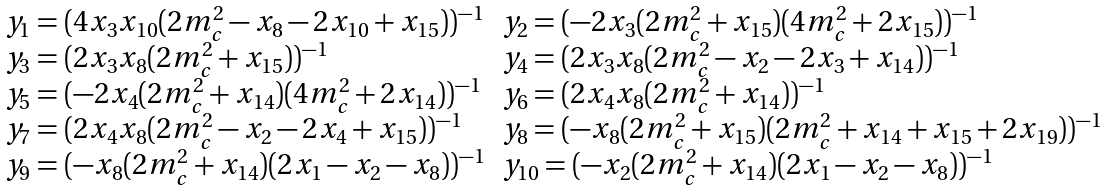Convert formula to latex. <formula><loc_0><loc_0><loc_500><loc_500>\begin{array} { l l l } & y _ { 1 } = ( 4 x _ { 3 } x _ { 1 0 } ( 2 { m ^ { 2 } _ { c } } - x _ { 8 } - 2 x _ { 1 0 } + x _ { 1 5 } ) ) ^ { - 1 } & y _ { 2 } = ( - 2 x _ { 3 } ( 2 { m ^ { 2 } _ { c } } + x _ { 1 5 } ) ( 4 { m ^ { 2 } _ { c } } + 2 x _ { 1 5 } ) ) ^ { - 1 } \\ & y _ { 3 } = ( 2 x _ { 3 } x _ { 8 } ( 2 { m ^ { 2 } _ { c } } + x _ { 1 5 } ) ) ^ { - 1 } & y _ { 4 } = ( 2 x _ { 3 } x _ { 8 } ( 2 { m ^ { 2 } _ { c } } - x _ { 2 } - 2 x _ { 3 } + x _ { 1 4 } ) ) ^ { - 1 } \\ & y _ { 5 } = ( - 2 x _ { 4 } ( 2 { m ^ { 2 } _ { c } } + x _ { 1 4 } ) ( 4 { m ^ { 2 } _ { c } } + 2 x _ { 1 4 } ) ) ^ { - 1 } & y _ { 6 } = ( 2 x _ { 4 } x _ { 8 } ( 2 { m ^ { 2 } _ { c } } + x _ { 1 4 } ) ) ^ { - 1 } \\ & y _ { 7 } = ( 2 x _ { 4 } x _ { 8 } ( 2 { m ^ { 2 } _ { c } } - x _ { 2 } - 2 x _ { 4 } + x _ { 1 5 } ) ) ^ { - 1 } & y _ { 8 } = ( - x _ { 8 } ( 2 { m ^ { 2 } _ { c } } + x _ { 1 5 } ) ( 2 { m ^ { 2 } _ { c } } + x _ { 1 4 } + x _ { 1 5 } + 2 x _ { 1 9 } ) ) ^ { - 1 } \\ & y _ { 9 } = ( - x _ { 8 } ( 2 { m ^ { 2 } _ { c } } + x _ { 1 4 } ) ( 2 x _ { 1 } - x _ { 2 } - x _ { 8 } ) ) ^ { - 1 } & y _ { 1 0 } = ( - x _ { 2 } ( 2 { m ^ { 2 } _ { c } } + x _ { 1 4 } ) ( 2 x _ { 1 } - x _ { 2 } - x _ { 8 } ) ) ^ { - 1 } \\ \end{array}</formula> 